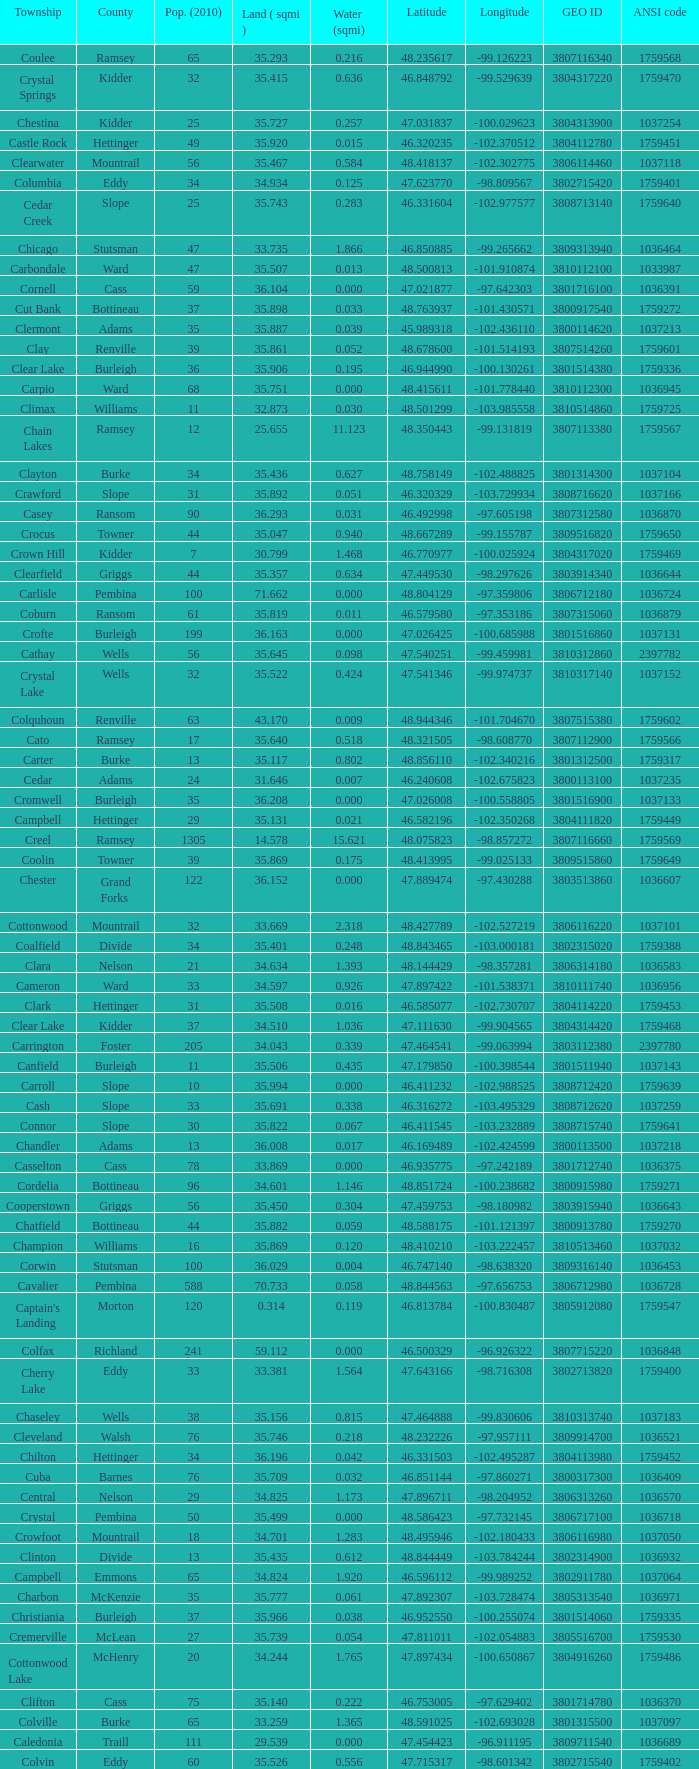What was the land area in sqmi that has a latitude of 48.763937? 35.898. 